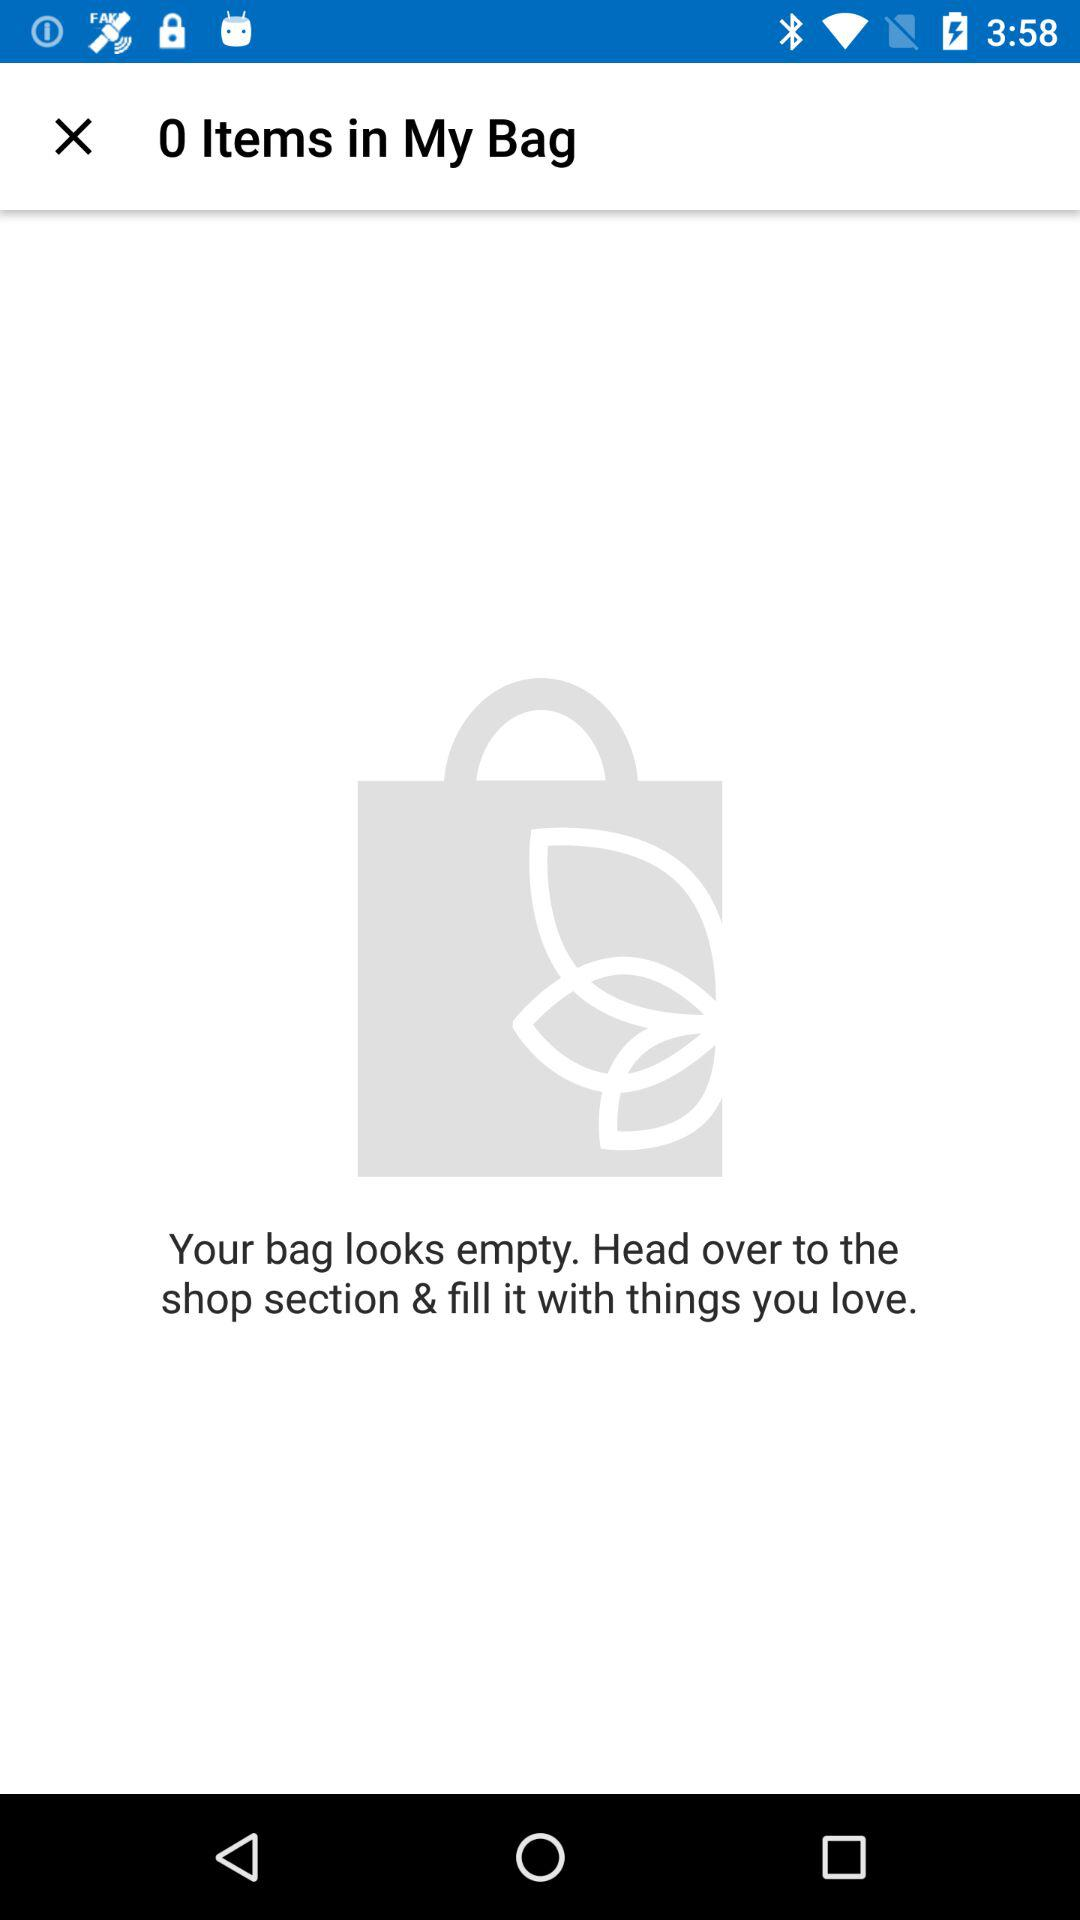How many items are in my bag?
Answer the question using a single word or phrase. 0 